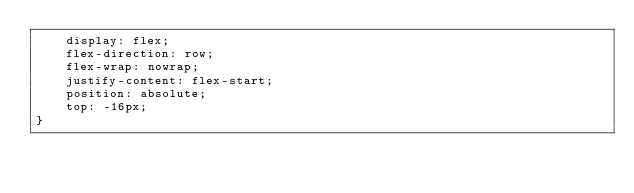<code> <loc_0><loc_0><loc_500><loc_500><_CSS_>    display: flex;
    flex-direction: row;
    flex-wrap: nowrap;
    justify-content: flex-start;
    position: absolute;
    top: -16px;
}</code> 